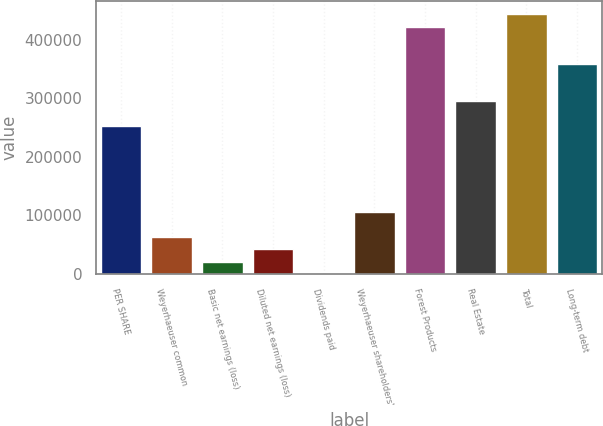<chart> <loc_0><loc_0><loc_500><loc_500><bar_chart><fcel>PER SHARE<fcel>Weyerhaeuser common<fcel>Basic net earnings (loss)<fcel>Diluted net earnings (loss)<fcel>Dividends paid<fcel>Weyerhaeuser shareholders'<fcel>Forest Products<fcel>Real Estate<fcel>Total<fcel>Long-term debt<nl><fcel>253509<fcel>63379.1<fcel>21128<fcel>42253.5<fcel>2.4<fcel>105630<fcel>422514<fcel>295760<fcel>443639<fcel>359137<nl></chart> 